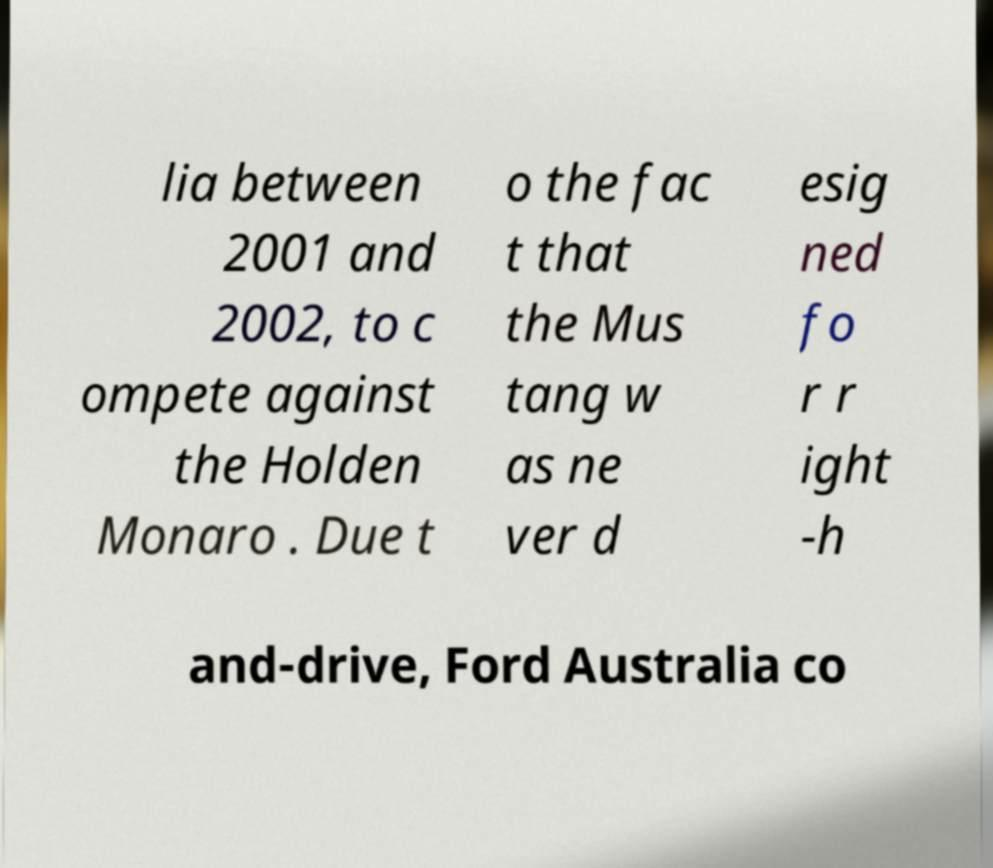Please identify and transcribe the text found in this image. lia between 2001 and 2002, to c ompete against the Holden Monaro . Due t o the fac t that the Mus tang w as ne ver d esig ned fo r r ight -h and-drive, Ford Australia co 